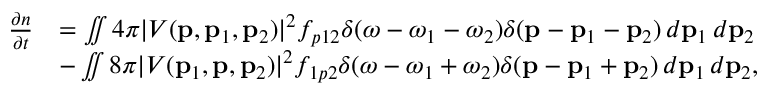<formula> <loc_0><loc_0><loc_500><loc_500>\begin{array} { r l } { \frac { \partial n } { \partial t } } & { = \iint 4 \pi | V ( p , p _ { 1 } , p _ { 2 } ) | ^ { 2 } f _ { p 1 2 } \delta ( \omega - \omega _ { 1 } - \omega _ { 2 } ) \delta ( p - p _ { 1 } - p _ { 2 } ) \, d p _ { 1 } \, d p _ { 2 } } \\ & { - \iint 8 \pi | V ( p _ { 1 } , p , p _ { 2 } ) | ^ { 2 } f _ { 1 p 2 } \delta ( \omega - \omega _ { 1 } + \omega _ { 2 } ) \delta ( p - p _ { 1 } + p _ { 2 } ) \, d p _ { 1 } \, d p _ { 2 } , } \end{array}</formula> 